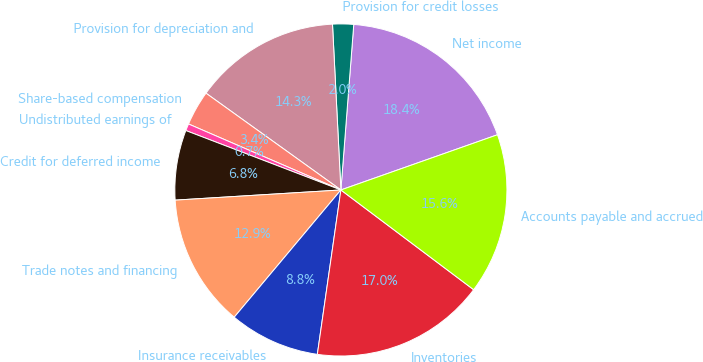Convert chart. <chart><loc_0><loc_0><loc_500><loc_500><pie_chart><fcel>Net income<fcel>Provision for credit losses<fcel>Provision for depreciation and<fcel>Share-based compensation<fcel>Undistributed earnings of<fcel>Credit for deferred income<fcel>Trade notes and financing<fcel>Insurance receivables<fcel>Inventories<fcel>Accounts payable and accrued<nl><fcel>18.37%<fcel>2.04%<fcel>14.29%<fcel>3.4%<fcel>0.68%<fcel>6.8%<fcel>12.92%<fcel>8.84%<fcel>17.01%<fcel>15.65%<nl></chart> 